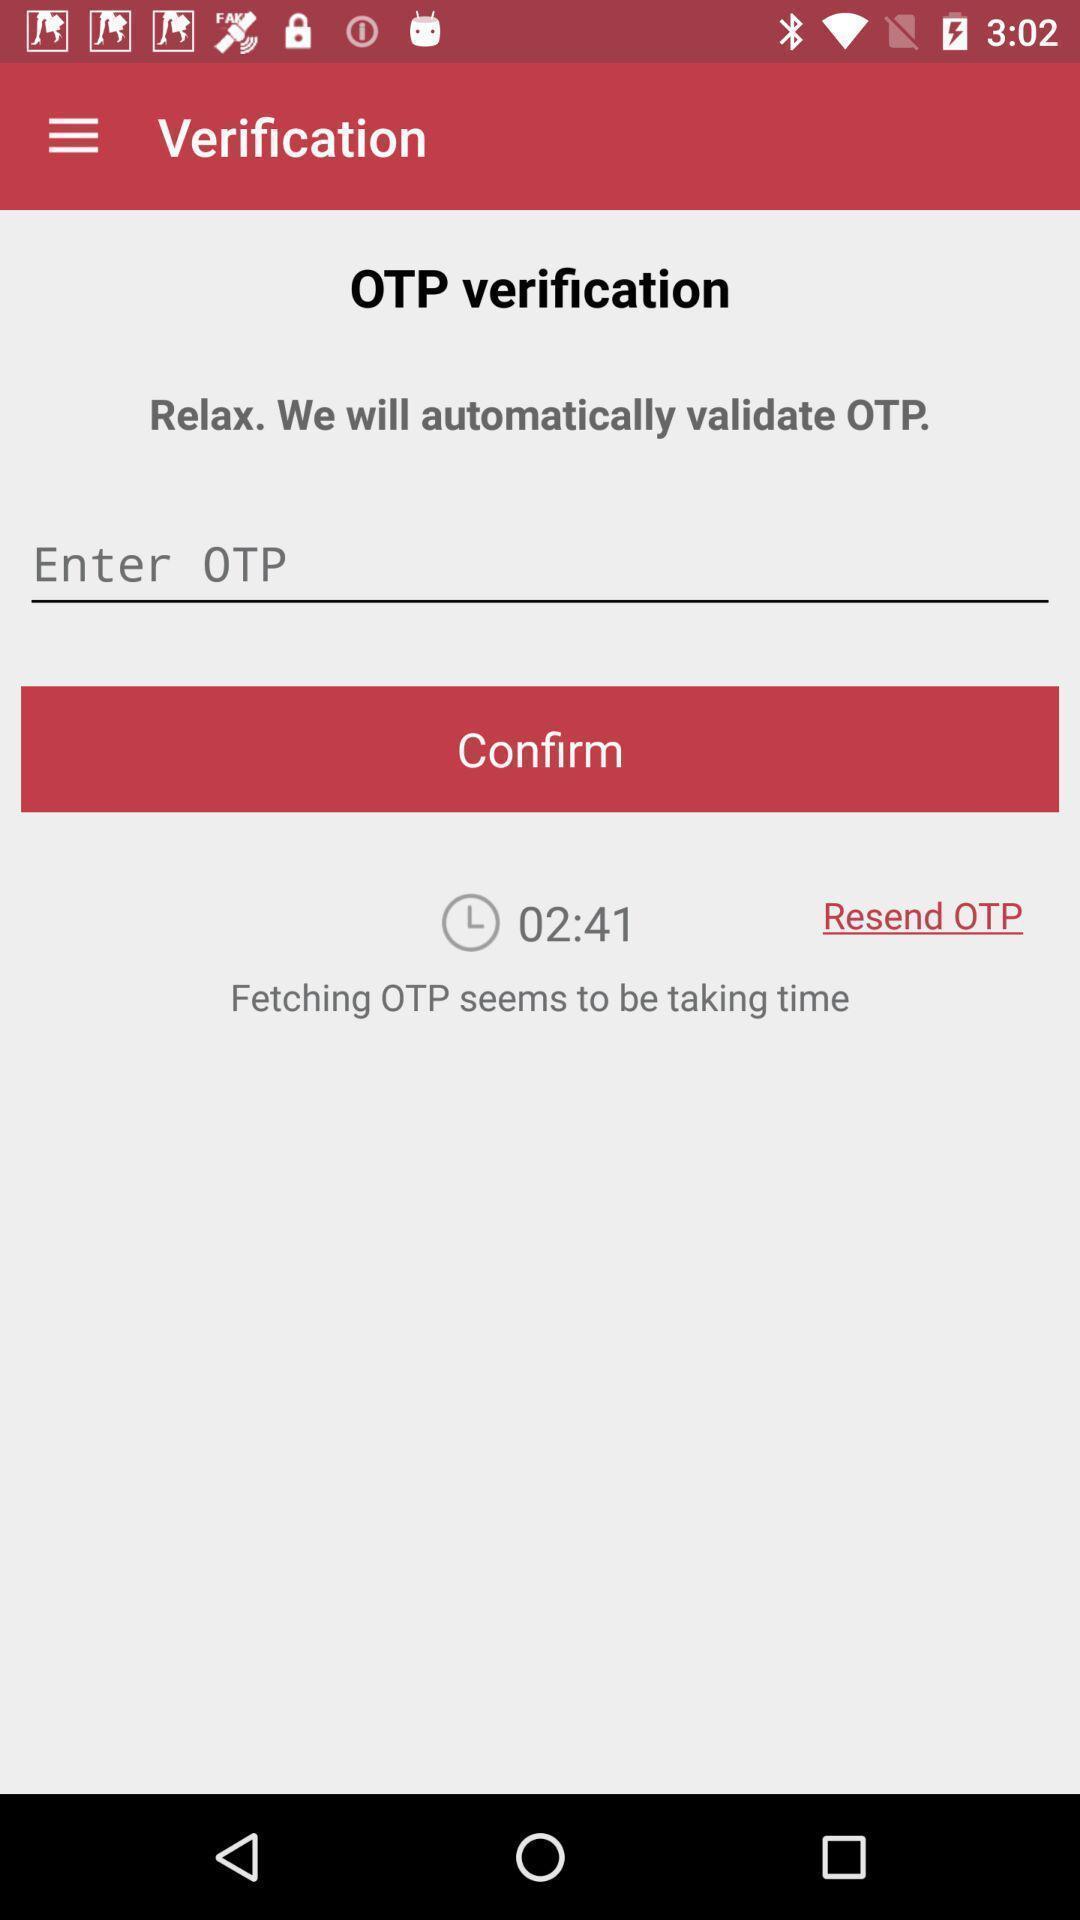Explain the elements present in this screenshot. Verification page. 